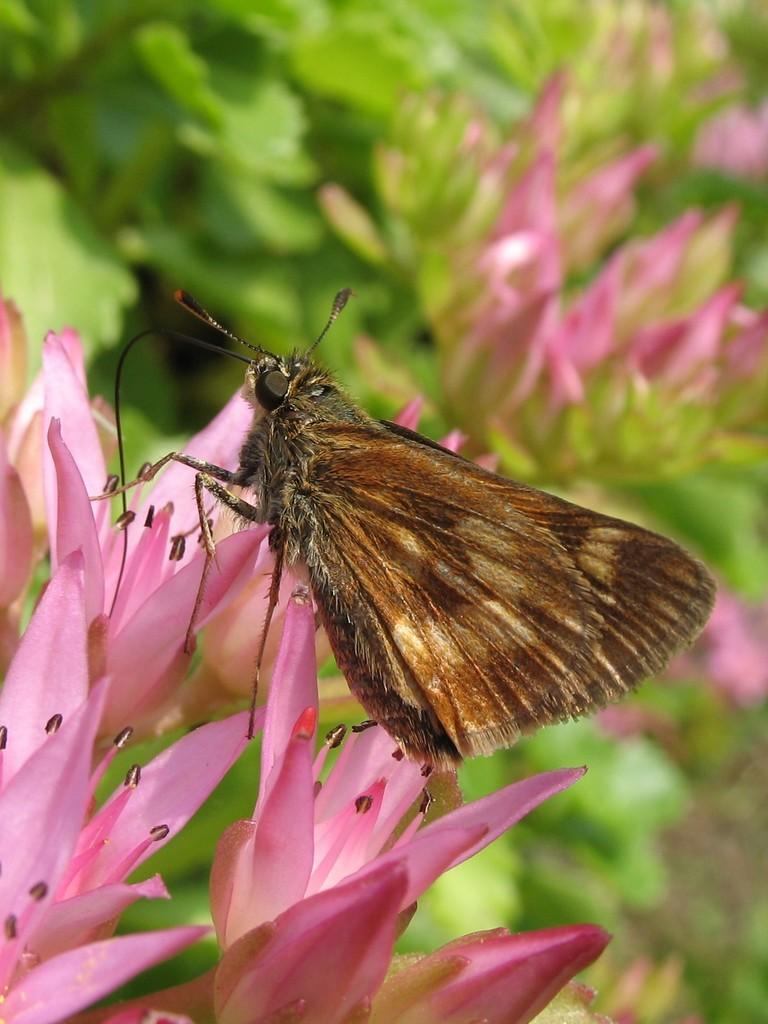What type of animal can be seen in the image? There is a butterfly in the image. What other living organisms are present in the image? There are flowers in the image. What can be seen in the background of the image? There are plants in the background of the image. What type of pen is the butterfly holding in the image? There is no pen present in the image, as butterflies do not hold pens. 